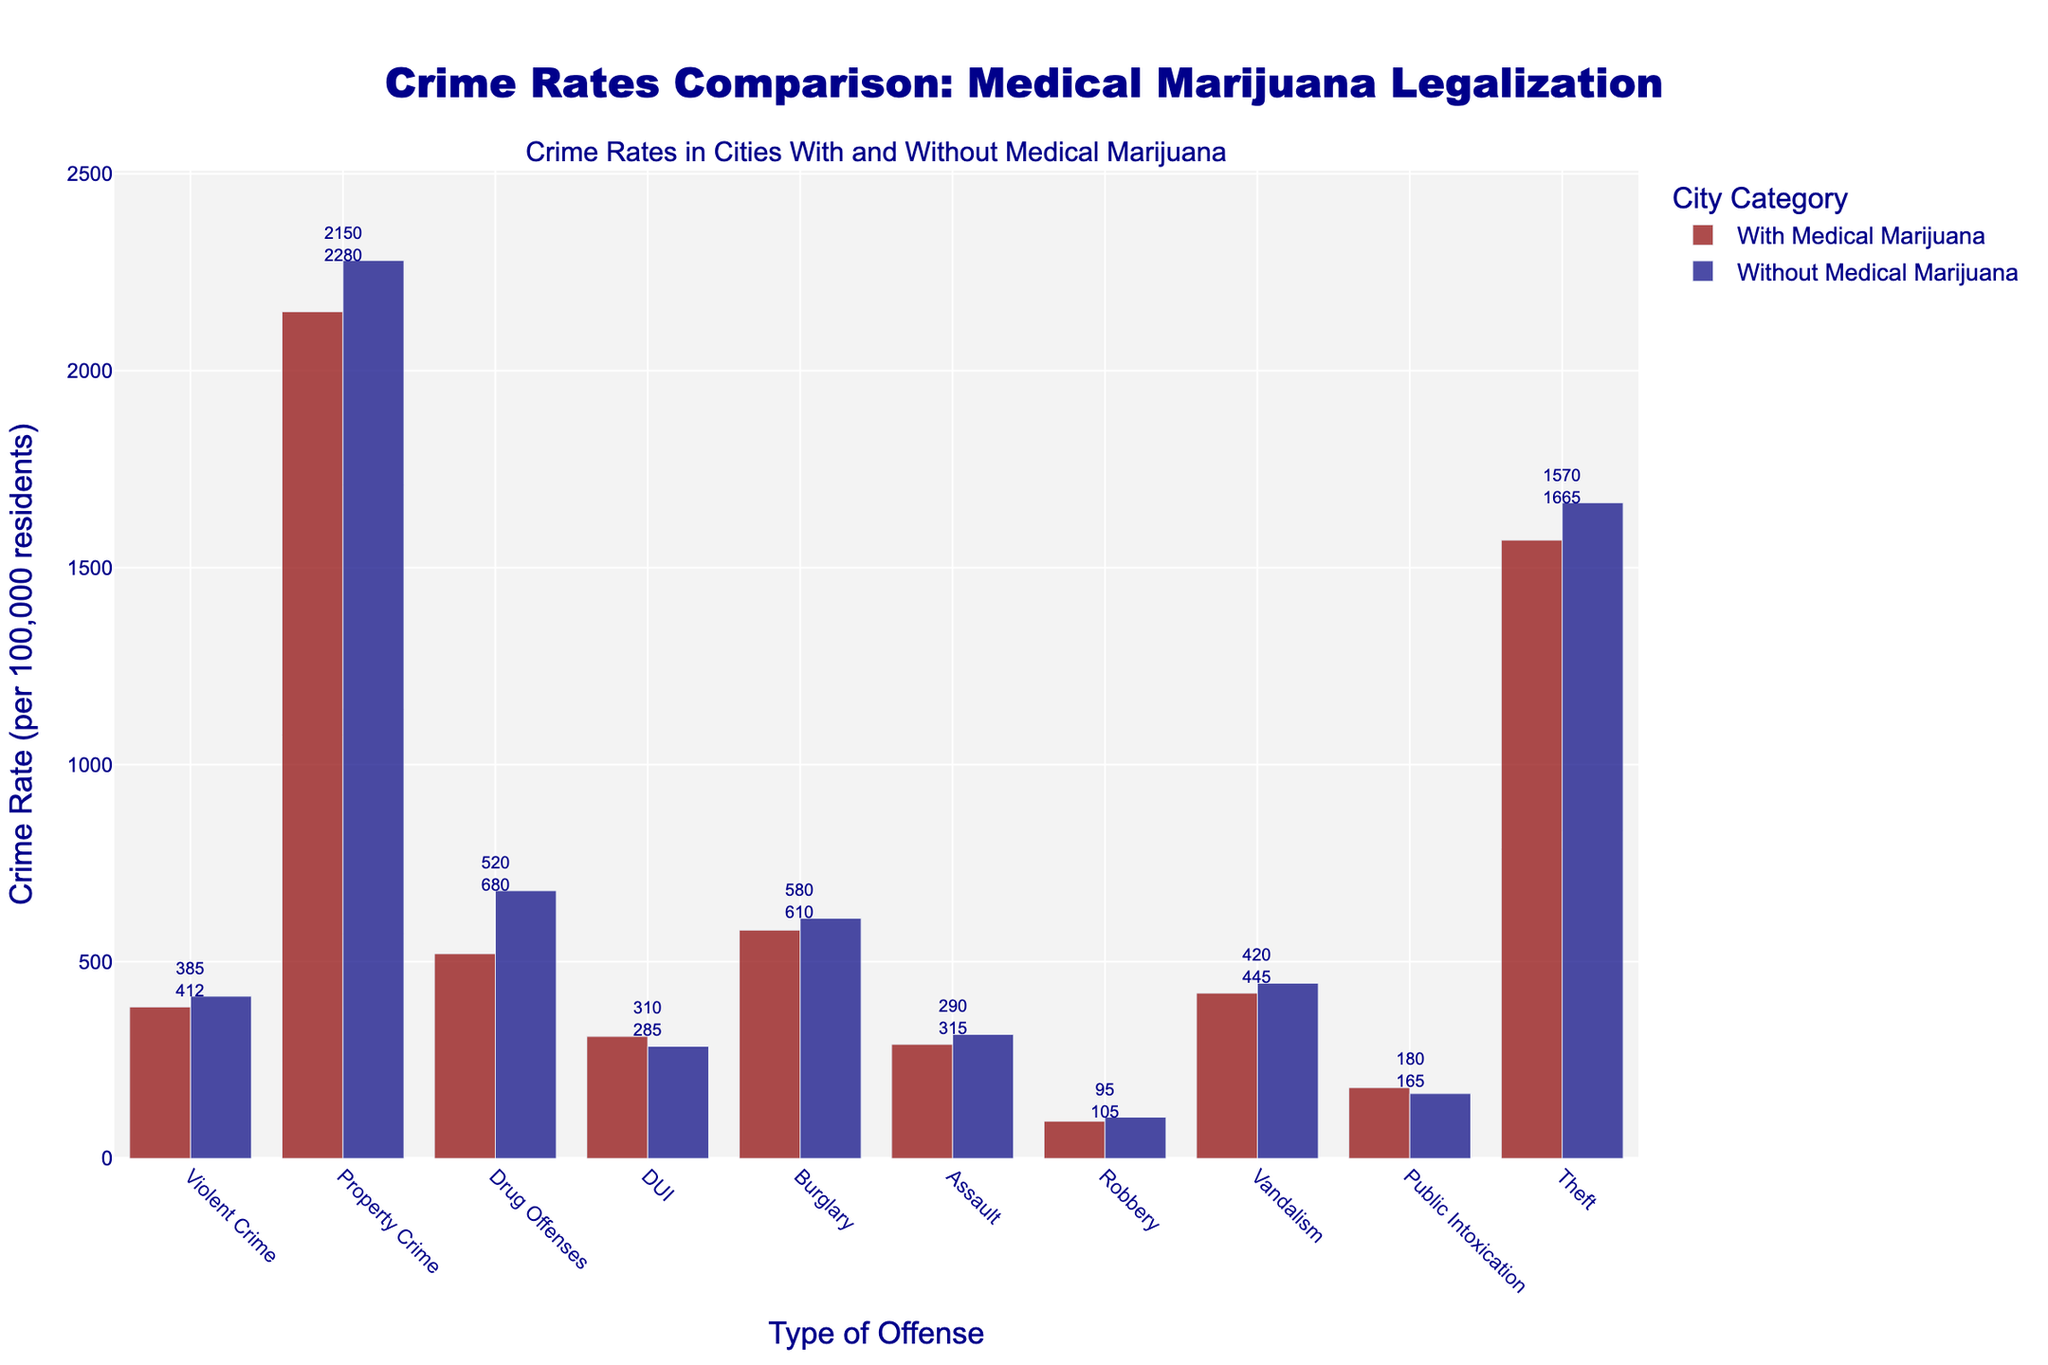Which crime type has the highest rate in cities without medical marijuana? The tallest blue bar is for Property Crime, indicating it has the highest rate among the offenses in cities without medical marijuana.
Answer: Property Crime What is the difference in the rate of Drug Offenses between cities with and without medical marijuana? The red bar for Drug Offenses (cities with medical marijuana) is at 520, and the blue bar (cities without medical marijuana) is at 680. The difference is 680 - 520 = 160.
Answer: 160 Which crime types have higher rates in cities with medical marijuana compared to cities without? Visually, red bars that are taller than the corresponding blue bars are for Public Intoxication and DUI.
Answer: Public Intoxication, DUI What is the total crime rate for Property Crime and Burglary in cities with medical marijuana? The rate for Property Crime is 2150 and for Burglary is 580. Summing them up, 2150 + 580 = 2730.
Answer: 2730 Are Property Crime rates in cities with medical marijuana higher or lower than those in cities without? The blue bar for Property Crime (without medical marijuana) is taller than the red one, indicating higher rates in cities without medical marijuana.
Answer: Lower Which type of crime shows the smallest absolute difference in rates between cities with and without medical marijuana? By comparing the heights of the bars, Vandalism shows the smallest difference with the red bar at 420 and the blue bar at 445, giving an absolute difference of 25.
Answer: Vandalism How does the rate of DUI in cities with medical marijuana compare to that in cities without? The red bar for DUI is at 310 while the blue bar is at 285, making the rate in cities with medical marijuana higher.
Answer: Higher What is the sum of the rates for Assault and Robbery in cities without medical marijuana? The rate for Assault is 315 and for Robbery is 105. Adding them together, 315 + 105 = 420.
Answer: 420 Which has a greater difference in rates: Vandalism or Assault between cities with and without medical marijuana? The absolute difference for Vandalism is 445 - 420 = 25, and for Assault is 315 - 290 = 25. Both differences are equal.
Answer: Equal Comparing the combined rates of Theft and Public Intoxication between cities with and without medical marijuana, which is higher? For cities with medical marijuana: 1570 (Theft) + 180 (Public Intoxication) = 1750. For cities without: 1665 (Theft) + 165 (Public Intoxication) = 1830. Since 1830 > 1750, it is higher in cities without medical marijuana.
Answer: Cities without medical marijuana 